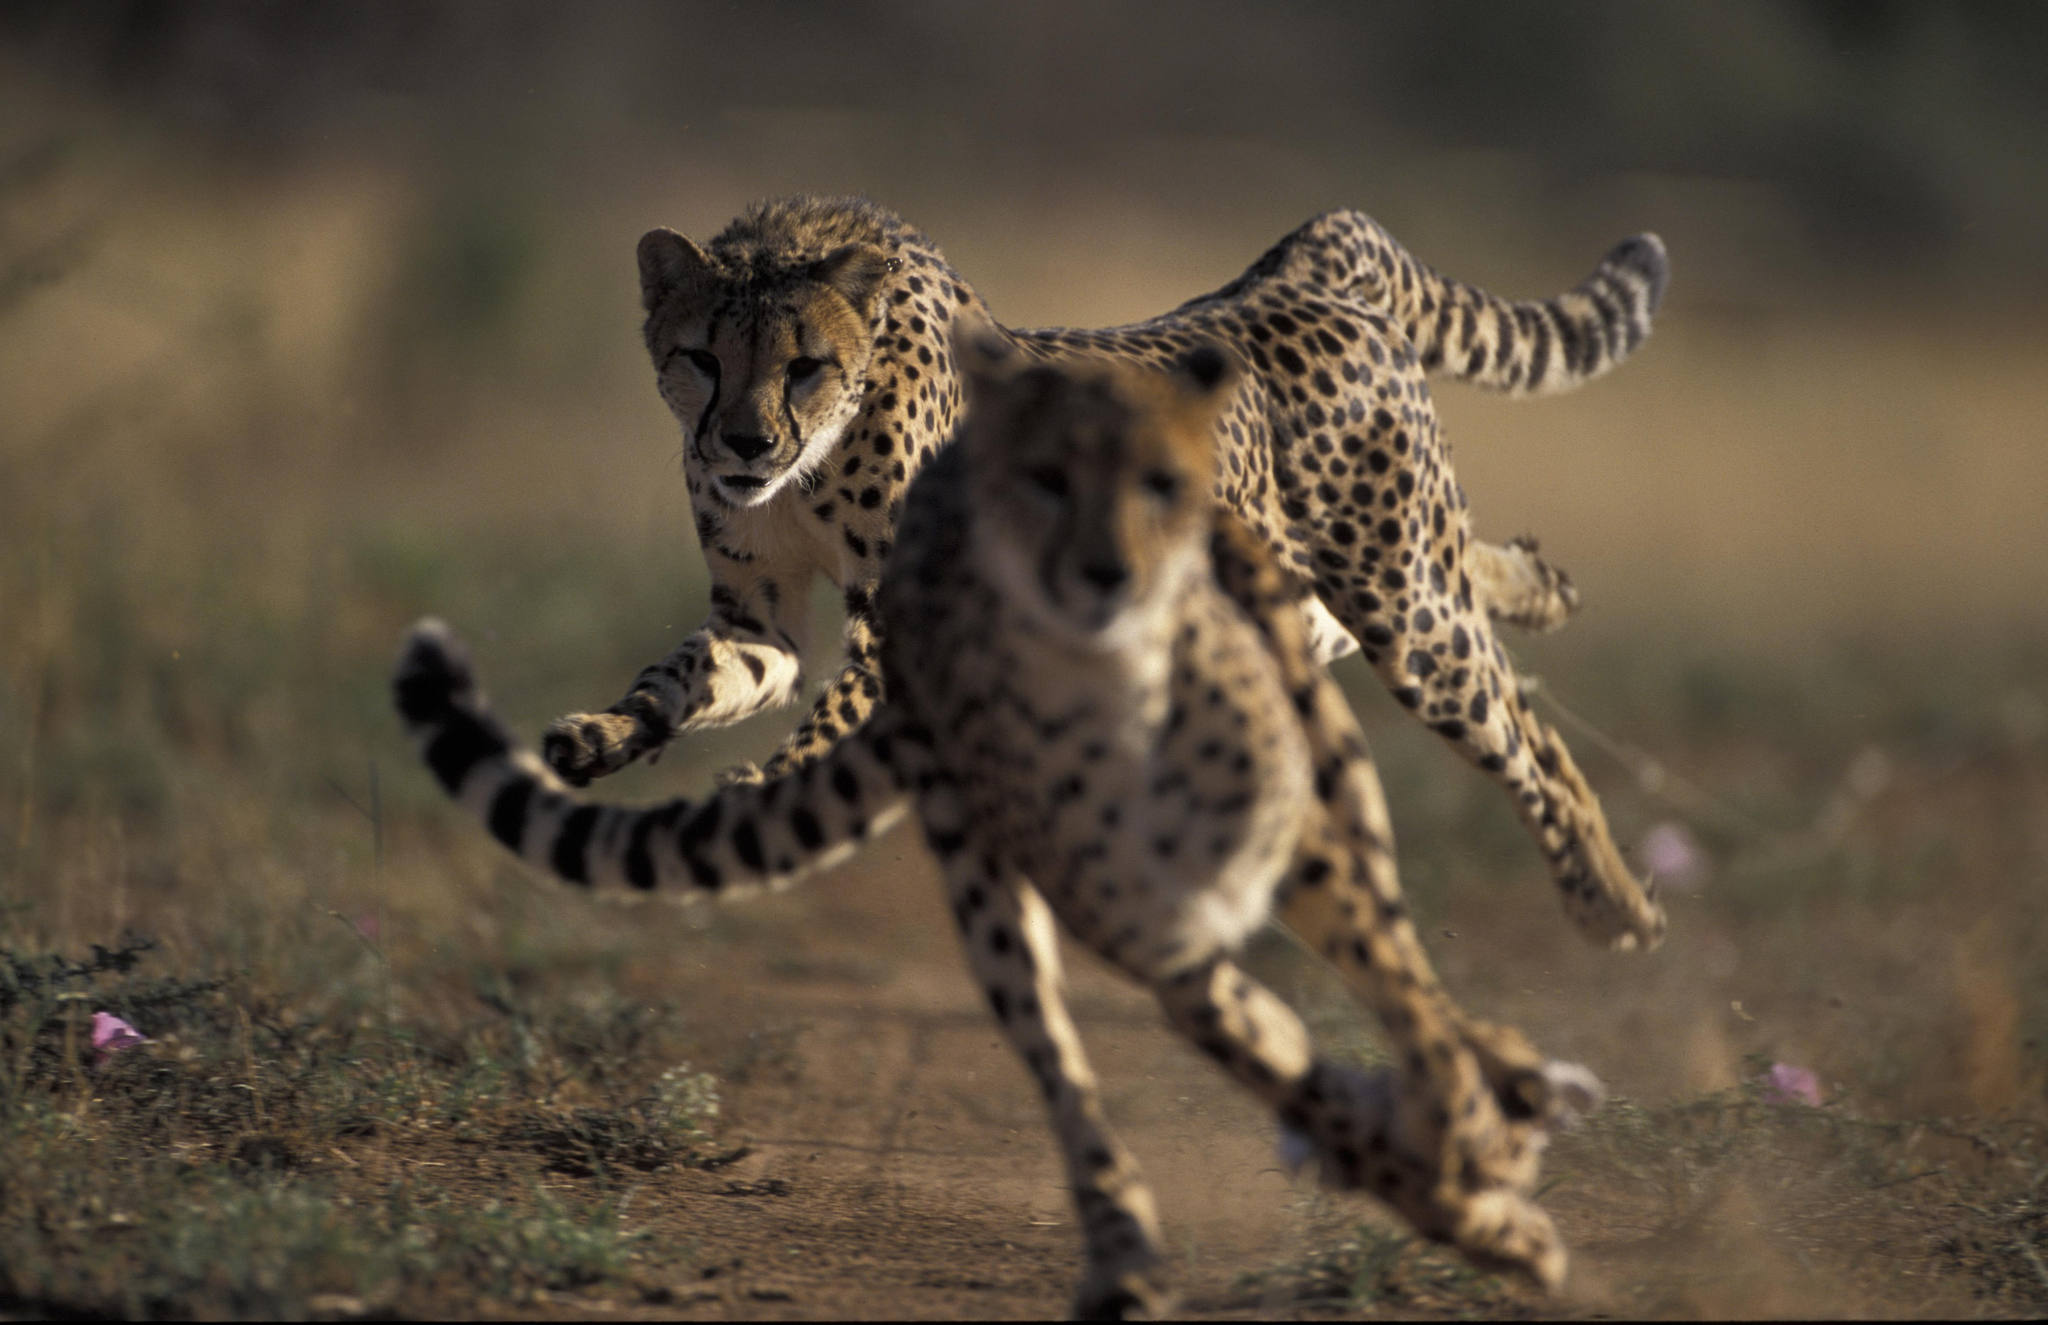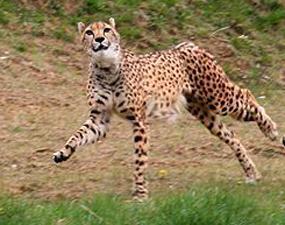The first image is the image on the left, the second image is the image on the right. For the images shown, is this caption "In at least one image there is a single leopard whose facing is left forward." true? Answer yes or no. Yes. The first image is the image on the left, the second image is the image on the right. For the images displayed, is the sentence "One image contains exactly one cheetah, which faces the camera, and the other image contains cheetahs with overlapping bodies." factually correct? Answer yes or no. Yes. 